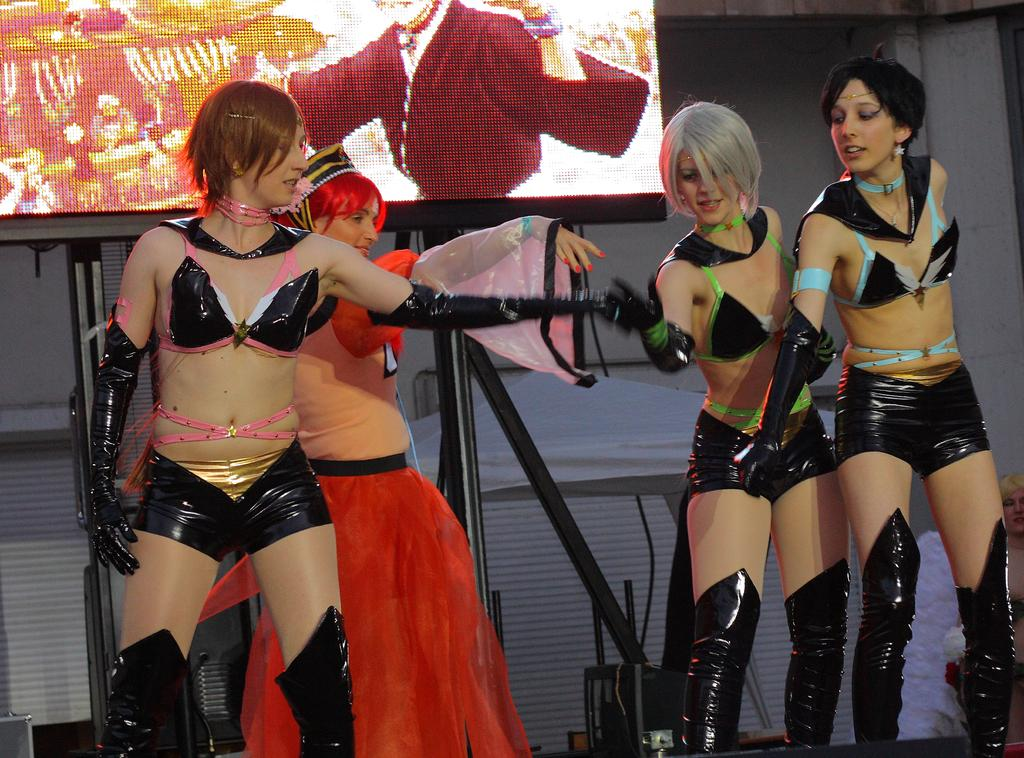How many women are on the stage in the foreground? There are four women on the stage in the foreground. What can be seen in the background of the image? In the background, there is a stand, a screen, and a wall. What can be inferred about the location of the image? The image is likely taken on a scene on a stage, given the presence of a stage and the stand, screen, and wall in the background. What year is depicted in the image? The image does not depict a specific year; it is a photograph of a scene on a stage. Is there a flame visible in the image? No, there is no flame present in the image. 